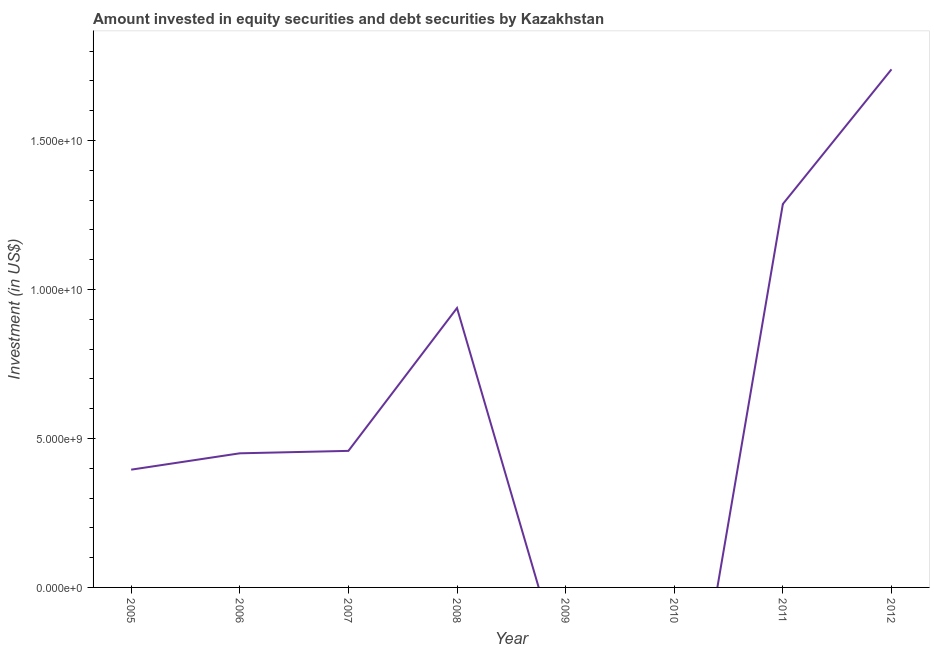What is the portfolio investment in 2009?
Your answer should be very brief. 0. Across all years, what is the maximum portfolio investment?
Provide a short and direct response. 1.74e+1. In which year was the portfolio investment maximum?
Your answer should be very brief. 2012. What is the sum of the portfolio investment?
Provide a succinct answer. 5.27e+1. What is the difference between the portfolio investment in 2006 and 2008?
Provide a succinct answer. -4.88e+09. What is the average portfolio investment per year?
Offer a terse response. 6.58e+09. What is the median portfolio investment?
Provide a succinct answer. 4.54e+09. In how many years, is the portfolio investment greater than 3000000000 US$?
Keep it short and to the point. 6. What is the ratio of the portfolio investment in 2008 to that in 2011?
Offer a very short reply. 0.73. Is the portfolio investment in 2006 less than that in 2011?
Make the answer very short. Yes. What is the difference between the highest and the second highest portfolio investment?
Your response must be concise. 4.52e+09. What is the difference between the highest and the lowest portfolio investment?
Offer a terse response. 1.74e+1. Does the portfolio investment monotonically increase over the years?
Provide a short and direct response. No. How many lines are there?
Your response must be concise. 1. How many years are there in the graph?
Keep it short and to the point. 8. What is the title of the graph?
Provide a short and direct response. Amount invested in equity securities and debt securities by Kazakhstan. What is the label or title of the Y-axis?
Your answer should be very brief. Investment (in US$). What is the Investment (in US$) in 2005?
Offer a very short reply. 3.95e+09. What is the Investment (in US$) of 2006?
Provide a short and direct response. 4.50e+09. What is the Investment (in US$) of 2007?
Keep it short and to the point. 4.58e+09. What is the Investment (in US$) of 2008?
Offer a terse response. 9.38e+09. What is the Investment (in US$) of 2011?
Your answer should be very brief. 1.29e+1. What is the Investment (in US$) in 2012?
Your response must be concise. 1.74e+1. What is the difference between the Investment (in US$) in 2005 and 2006?
Make the answer very short. -5.49e+08. What is the difference between the Investment (in US$) in 2005 and 2007?
Provide a short and direct response. -6.30e+08. What is the difference between the Investment (in US$) in 2005 and 2008?
Your response must be concise. -5.42e+09. What is the difference between the Investment (in US$) in 2005 and 2011?
Offer a terse response. -8.92e+09. What is the difference between the Investment (in US$) in 2005 and 2012?
Your answer should be very brief. -1.34e+1. What is the difference between the Investment (in US$) in 2006 and 2007?
Make the answer very short. -8.17e+07. What is the difference between the Investment (in US$) in 2006 and 2008?
Your answer should be compact. -4.88e+09. What is the difference between the Investment (in US$) in 2006 and 2011?
Provide a short and direct response. -8.37e+09. What is the difference between the Investment (in US$) in 2006 and 2012?
Make the answer very short. -1.29e+1. What is the difference between the Investment (in US$) in 2007 and 2008?
Provide a short and direct response. -4.79e+09. What is the difference between the Investment (in US$) in 2007 and 2011?
Ensure brevity in your answer.  -8.29e+09. What is the difference between the Investment (in US$) in 2007 and 2012?
Offer a very short reply. -1.28e+1. What is the difference between the Investment (in US$) in 2008 and 2011?
Offer a terse response. -3.49e+09. What is the difference between the Investment (in US$) in 2008 and 2012?
Your answer should be compact. -8.01e+09. What is the difference between the Investment (in US$) in 2011 and 2012?
Make the answer very short. -4.52e+09. What is the ratio of the Investment (in US$) in 2005 to that in 2006?
Your response must be concise. 0.88. What is the ratio of the Investment (in US$) in 2005 to that in 2007?
Provide a short and direct response. 0.86. What is the ratio of the Investment (in US$) in 2005 to that in 2008?
Provide a short and direct response. 0.42. What is the ratio of the Investment (in US$) in 2005 to that in 2011?
Your answer should be compact. 0.31. What is the ratio of the Investment (in US$) in 2005 to that in 2012?
Your answer should be very brief. 0.23. What is the ratio of the Investment (in US$) in 2006 to that in 2007?
Your response must be concise. 0.98. What is the ratio of the Investment (in US$) in 2006 to that in 2008?
Make the answer very short. 0.48. What is the ratio of the Investment (in US$) in 2006 to that in 2012?
Make the answer very short. 0.26. What is the ratio of the Investment (in US$) in 2007 to that in 2008?
Provide a succinct answer. 0.49. What is the ratio of the Investment (in US$) in 2007 to that in 2011?
Keep it short and to the point. 0.36. What is the ratio of the Investment (in US$) in 2007 to that in 2012?
Keep it short and to the point. 0.26. What is the ratio of the Investment (in US$) in 2008 to that in 2011?
Your answer should be very brief. 0.73. What is the ratio of the Investment (in US$) in 2008 to that in 2012?
Ensure brevity in your answer.  0.54. What is the ratio of the Investment (in US$) in 2011 to that in 2012?
Your answer should be very brief. 0.74. 